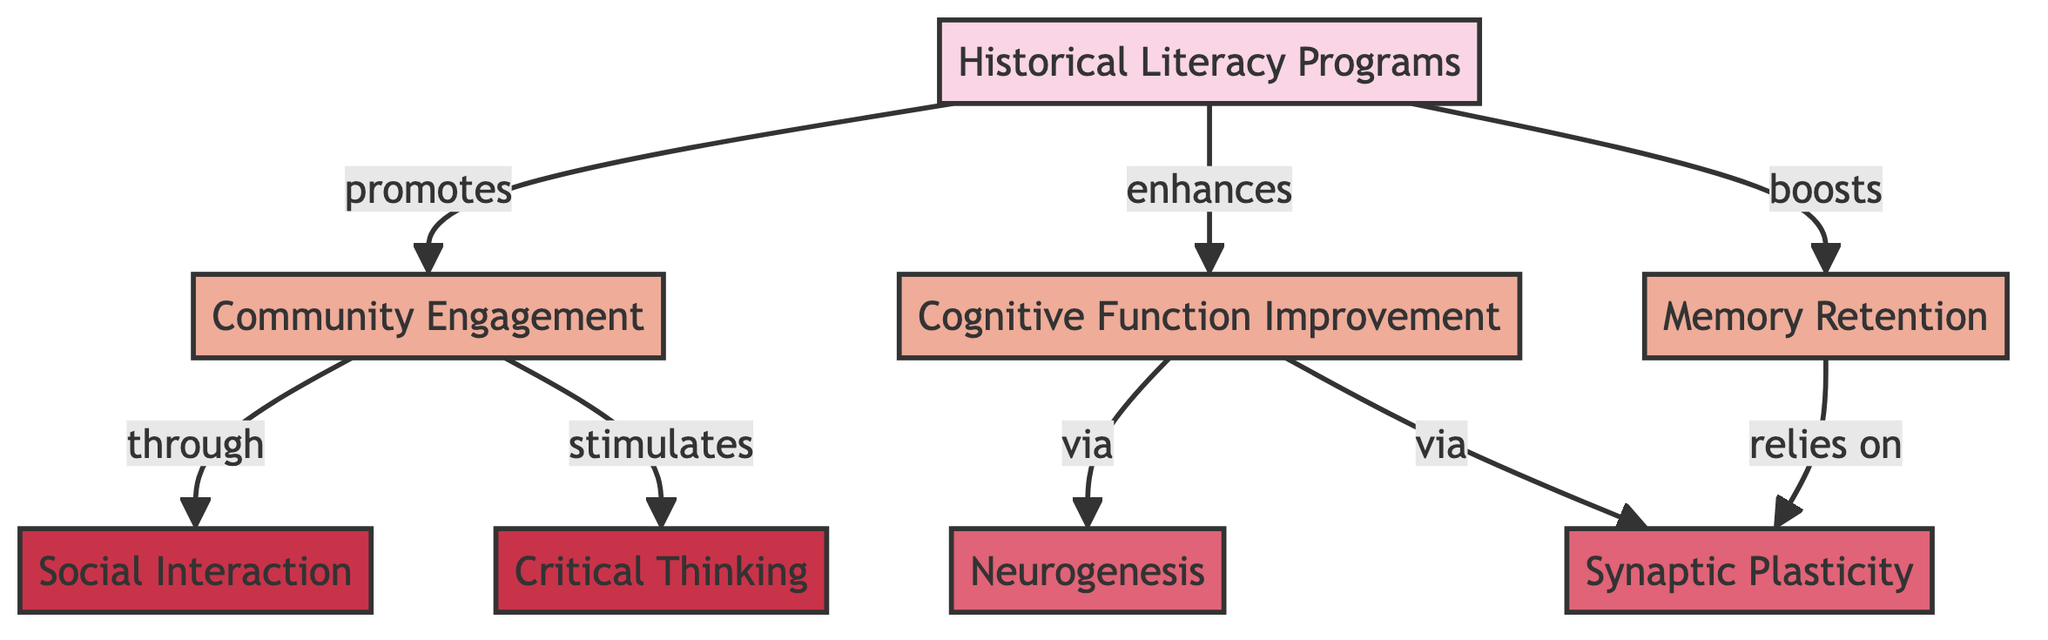What promotes community engagement? According to the diagram, historical literacy programs are shown to promote community engagement. This is illustrated by the direct directional arrow from "Historical Literacy Programs" to "Community Engagement," indicating a promoting relationship.
Answer: Historical Literacy Programs How many benefits are listed in the diagram? The diagram has three benefits listed: "Community Engagement," "Cognitive Function Improvement," and "Memory Retention." Counting these, we find a total of three benefits.
Answer: 3 What mechanism is associated with cognitive function improvement? The diagram shows that cognitive function improvement can occur via two mechanisms: "Neurogenesis" and "Synaptic Plasticity." Since the question only asks for one, one of the mechanisms identified is "Neurogenesis."
Answer: Neurogenesis Which activity stimulates critical thinking? The diagram indicates that community engagement stimulates critical thinking through a direct connection illustrated by the arrow leading from "Community Engagement" pointing to "Critical Thinking."
Answer: Community Engagement How does memory retention rely on synaptic plasticity? The diagram indicates memory retention relies on synaptic plasticity, marked by the arrow from "Memory Retention" to "Synaptic Plasticity." This shows that memory retention depends on the process of synaptic plasticity.
Answer: Synaptic Plasticity What improves cognitive function? The diagram clearly states that cognitive function improvement is enhanced by historical literacy programs. The arrow leading from "Historical Literacy Programs" to "Cognitive Function Improvement" specifies this enhancement relationship.
Answer: Historical Literacy Programs What activity is connected to community engagement? The diagram displays that social interaction is connected to community engagement through a direct relationship indicated by the arrow pointing from "Community Engagement" to "Social Interaction."
Answer: Social Interaction What does memory retention boost? The diagram demonstrates that memory retention boosts cognitive function improvement, as seen from the connection implied by the arrow from "Memory Retention" to "Cognitive Function Improvement."
Answer: Cognitive Function Improvement 